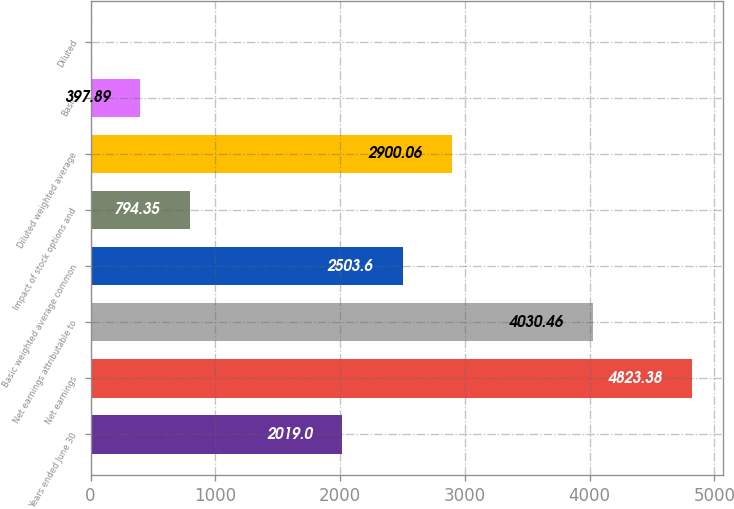<chart> <loc_0><loc_0><loc_500><loc_500><bar_chart><fcel>Years ended June 30<fcel>Net earnings<fcel>Net earnings attributable to<fcel>Basic weighted average common<fcel>Impact of stock options and<fcel>Diluted weighted average<fcel>Basic<fcel>Diluted<nl><fcel>2019<fcel>4823.38<fcel>4030.46<fcel>2503.6<fcel>794.35<fcel>2900.06<fcel>397.89<fcel>1.43<nl></chart> 